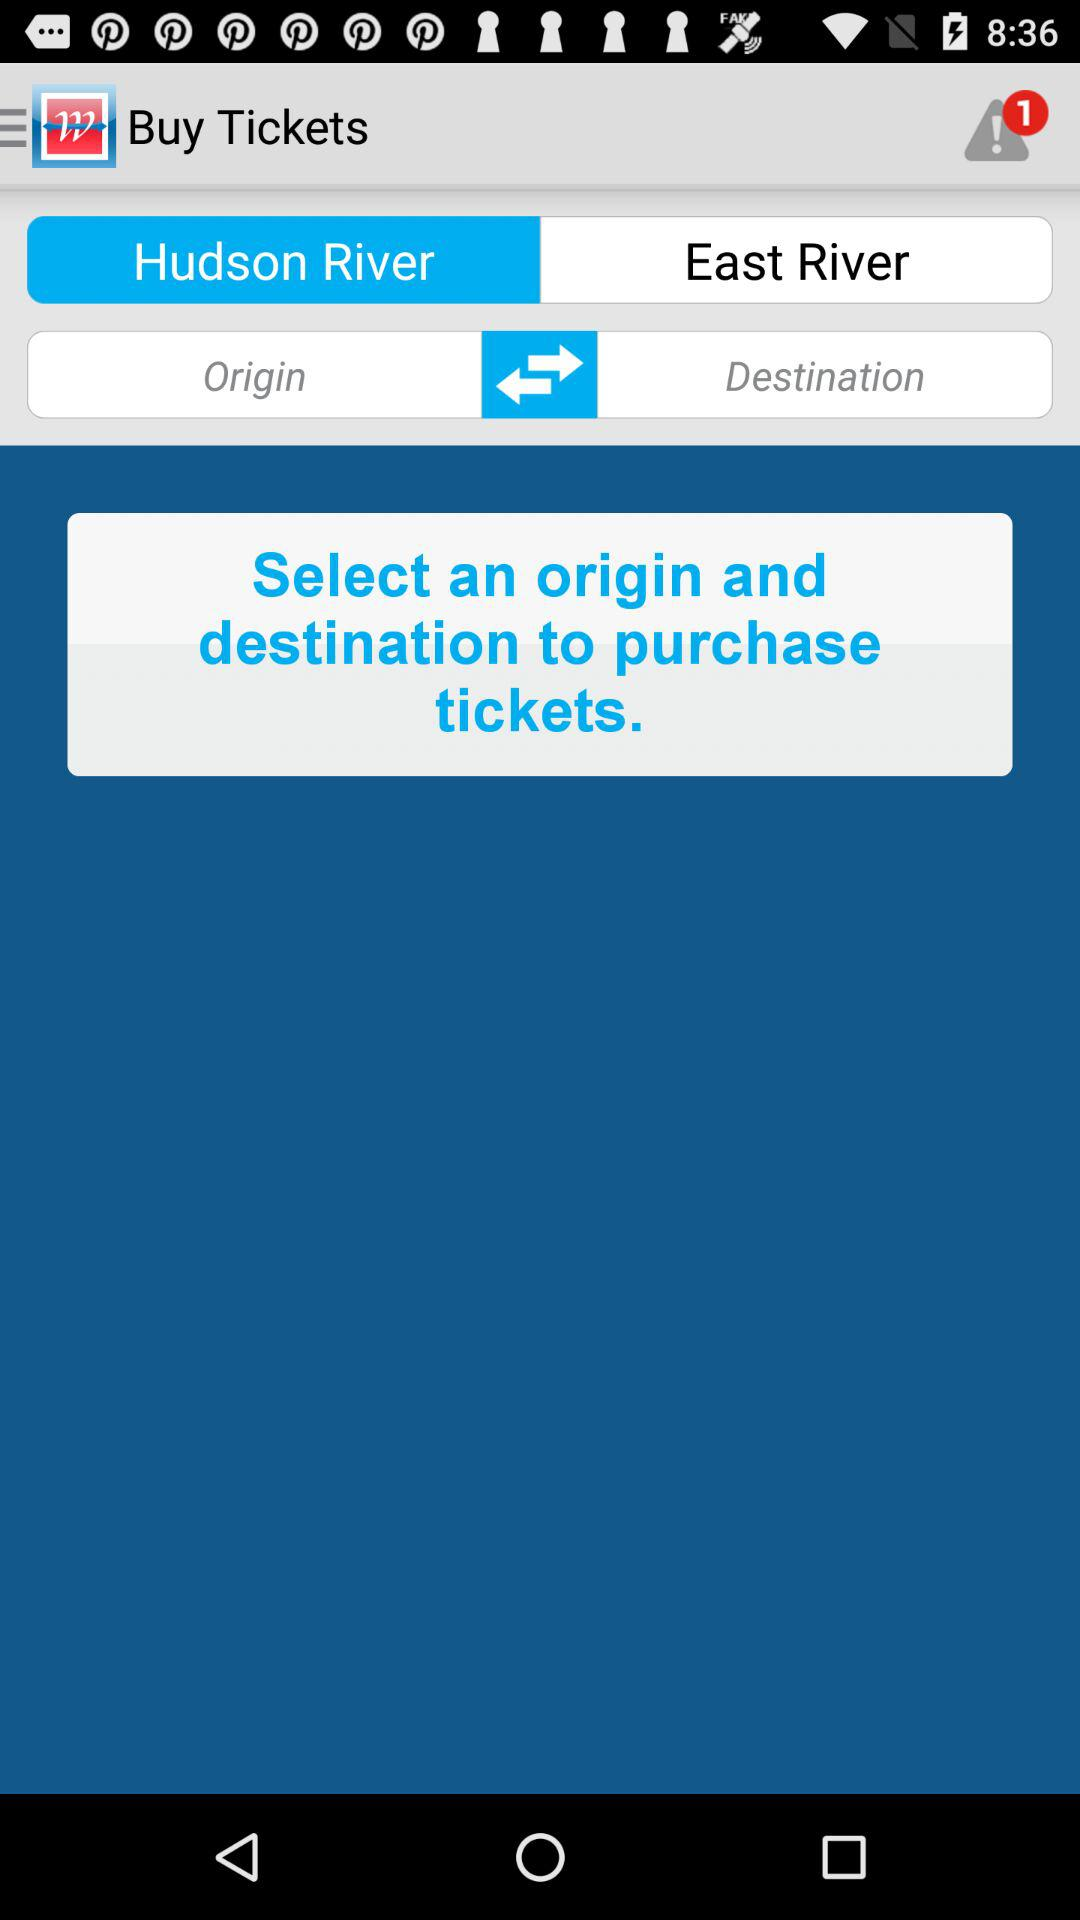What is the destination point? The destination point is "East River". 